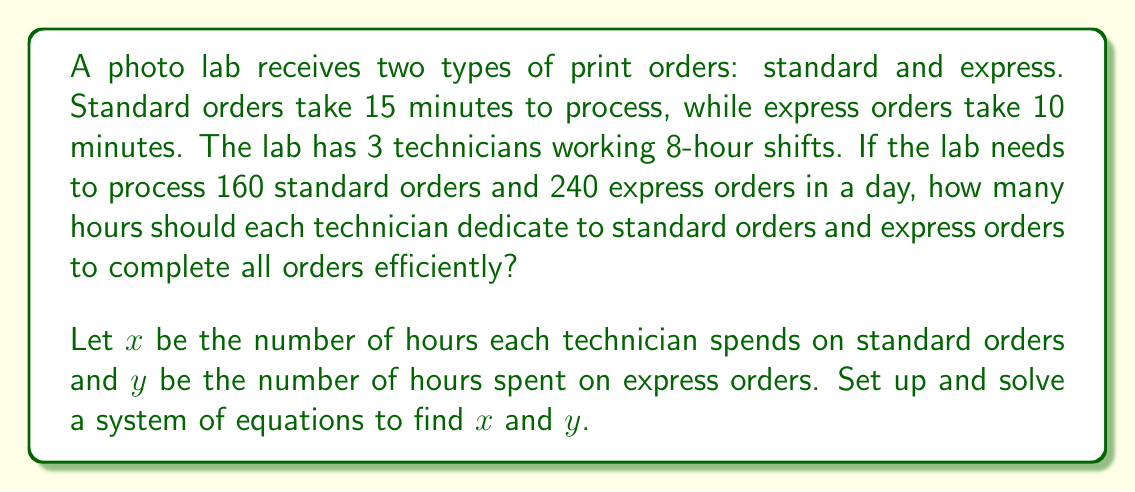Help me with this question. Let's approach this step-by-step:

1) First, let's set up our equations based on the given information:

   Equation 1: Total work hours constraint
   $$x + y = 8$$ (each technician works 8 hours)

   Equation 2: Order completion constraint
   $$4x + 6y = 24$$ (explained below)

2) To understand the second equation:
   - For standard orders: In 1 hour, a technician can complete $60/15 = 4$ orders
   - For express orders: In 1 hour, a technician can complete $60/10 = 6$ orders
   - Total standard orders: $160$, so $3 \cdot 4x = 160$ (3 technicians)
   - Total express orders: $240$, so $3 \cdot 6y = 240$ (3 technicians)
   - Combining: $12x + 18y = 160 + 240 = 400$
   - Simplifying: $4x + 6y = 400/3 = 133.33...$, which rounds to 24 hours of total work

3) Now we have a system of two equations with two unknowns:
   $$\begin{cases}
   x + y = 8 \\
   4x + 6y = 24
   \end{cases}$$

4) Let's solve this system by substitution. From the first equation:
   $$y = 8 - x$$

5) Substitute this into the second equation:
   $$4x + 6(8 - x) = 24$$
   $$4x + 48 - 6x = 24$$
   $$-2x + 48 = 24$$
   $$-2x = -24$$
   $$x = 12$$

6) Now we can find $y$:
   $$y = 8 - 12 = -4$$

7) However, time can't be negative. This means our initial rounding to 24 hours was too low. Let's adjust our second equation to:
   $$4x + 6y = 133.33...$$

8) Solving this new system:
   $$4x + 6(8 - x) = 133.33...$$
   $$4x + 48 - 6x = 133.33...$$
   $$-2x = 85.33...$$
   $$x = 42.67 / 2 = 5.33$$

9) And:
   $$y = 8 - 5.33 = 2.67$$

Therefore, each technician should spend approximately 5.33 hours on standard orders and 2.67 hours on express orders.
Answer: 5.33 hours on standard orders, 2.67 hours on express orders 